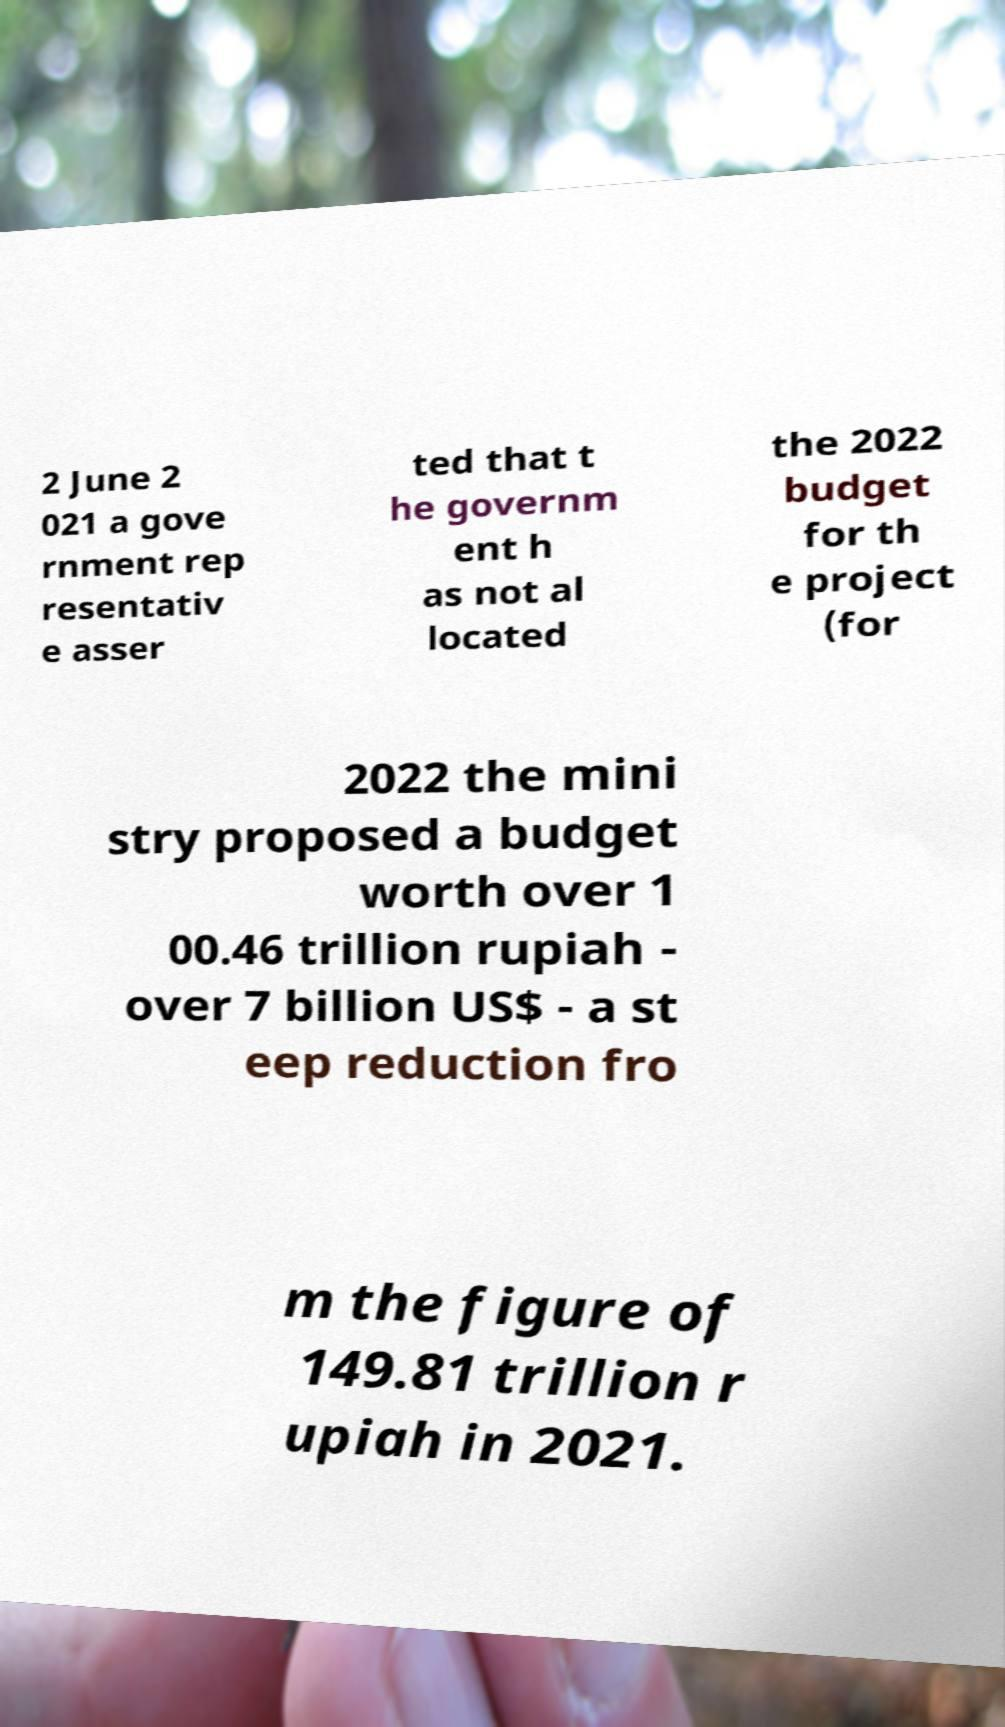Could you extract and type out the text from this image? 2 June 2 021 a gove rnment rep resentativ e asser ted that t he governm ent h as not al located the 2022 budget for th e project (for 2022 the mini stry proposed a budget worth over 1 00.46 trillion rupiah - over 7 billion US$ - a st eep reduction fro m the figure of 149.81 trillion r upiah in 2021. 